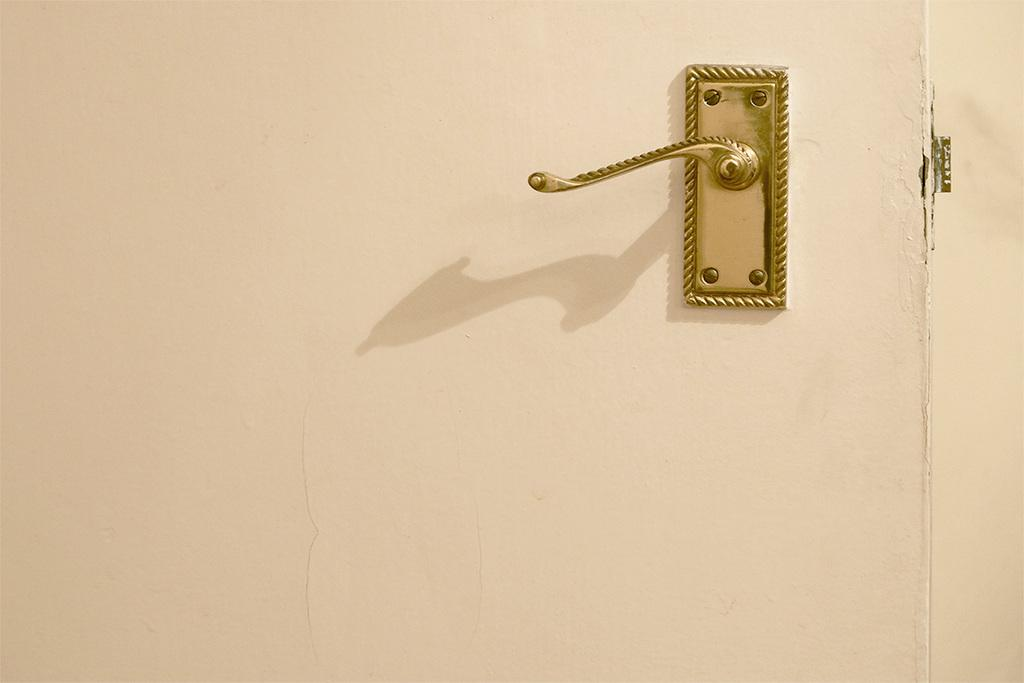What is located in the foreground of the image? There is a handle to a door in the foreground of the image. What can be seen on the right side of the image? There is a cream-colored wall on the right side of the image. What type of locket is hanging from the door handle in the image? There is no locket present in the image; it only features a handle to a door and a cream-colored wall. 